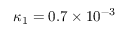<formula> <loc_0><loc_0><loc_500><loc_500>\kappa _ { 1 } = 0 . 7 \times 1 0 ^ { - 3 }</formula> 